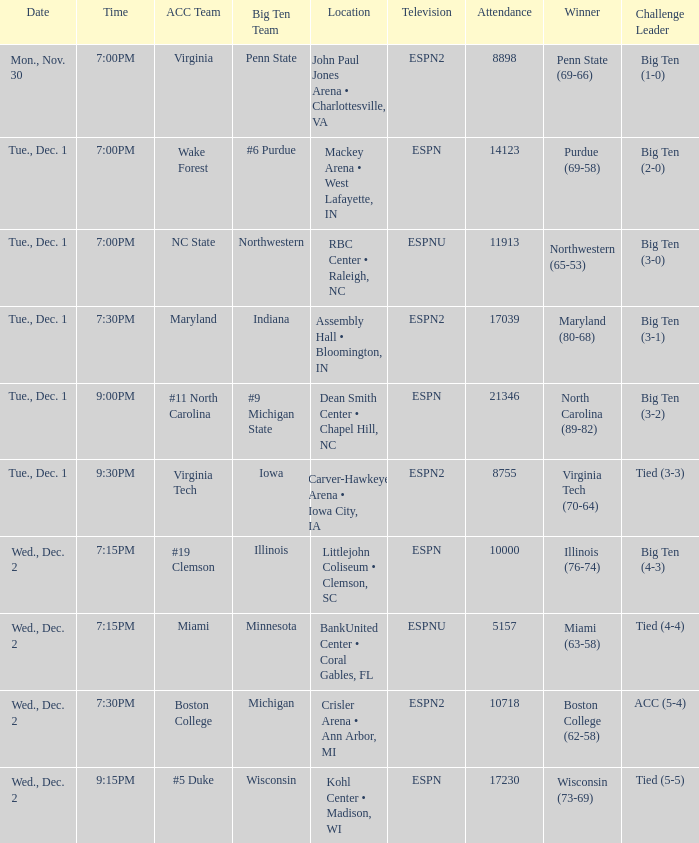Name the location for illinois Littlejohn Coliseum • Clemson, SC. 